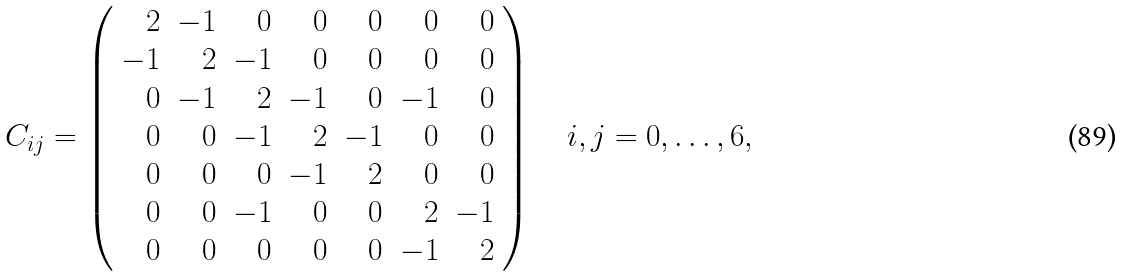<formula> <loc_0><loc_0><loc_500><loc_500>C _ { i j } = \left ( \begin{array} { r r r r r r r r r } 2 & - 1 & 0 & 0 & 0 & 0 & 0 \\ - 1 & 2 & - 1 & 0 & 0 & 0 & 0 \\ 0 & - 1 & 2 & - 1 & 0 & - 1 & 0 \\ 0 & 0 & - 1 & 2 & - 1 & 0 & 0 \\ 0 & 0 & 0 & - 1 & 2 & 0 & 0 \\ 0 & 0 & - 1 & 0 & 0 & 2 & - 1 \\ 0 & 0 & 0 & 0 & 0 & - 1 & 2 \\ \end{array} \right ) \quad i , j = 0 , \dots , 6 ,</formula> 